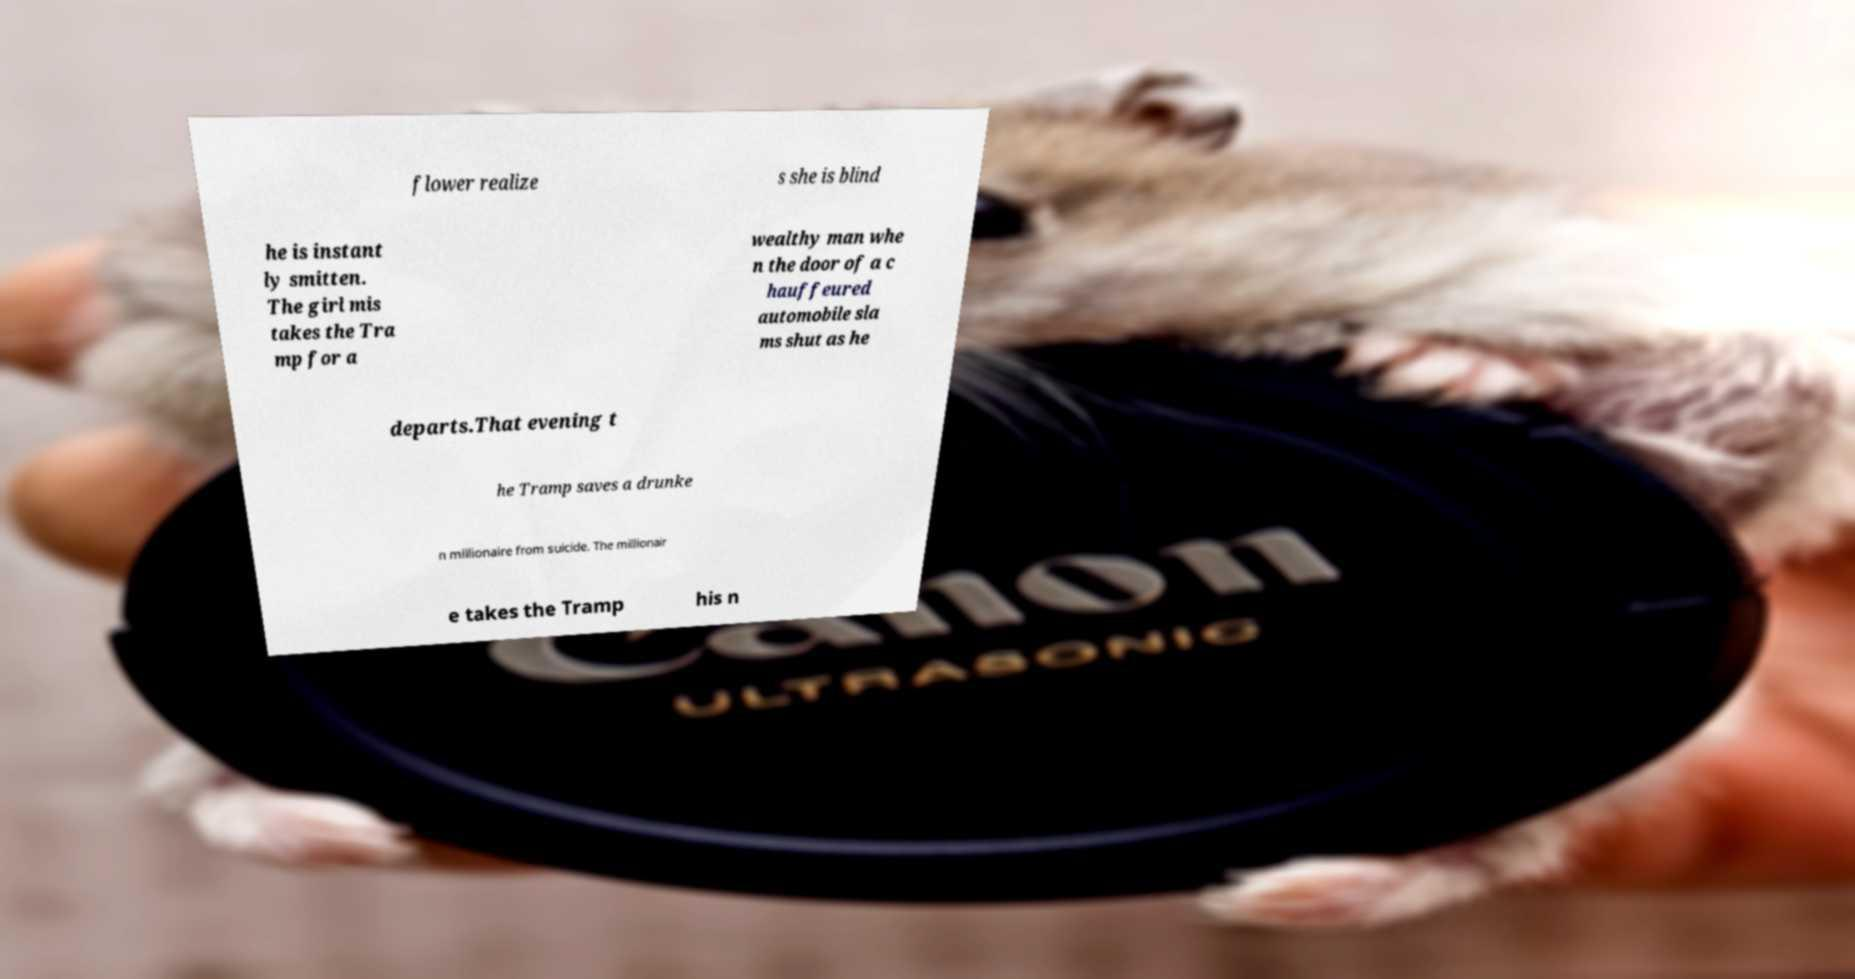What messages or text are displayed in this image? I need them in a readable, typed format. flower realize s she is blind he is instant ly smitten. The girl mis takes the Tra mp for a wealthy man whe n the door of a c hauffeured automobile sla ms shut as he departs.That evening t he Tramp saves a drunke n millionaire from suicide. The millionair e takes the Tramp his n 